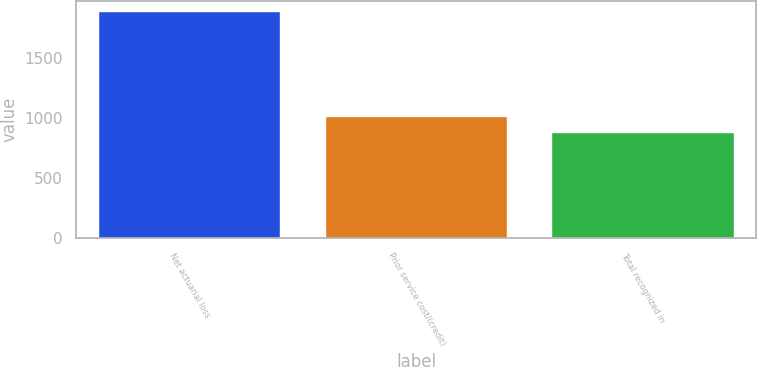Convert chart. <chart><loc_0><loc_0><loc_500><loc_500><bar_chart><fcel>Net actuarial loss<fcel>Prior service cost/(credit)<fcel>Total recognized in<nl><fcel>1885<fcel>1008<fcel>877<nl></chart> 